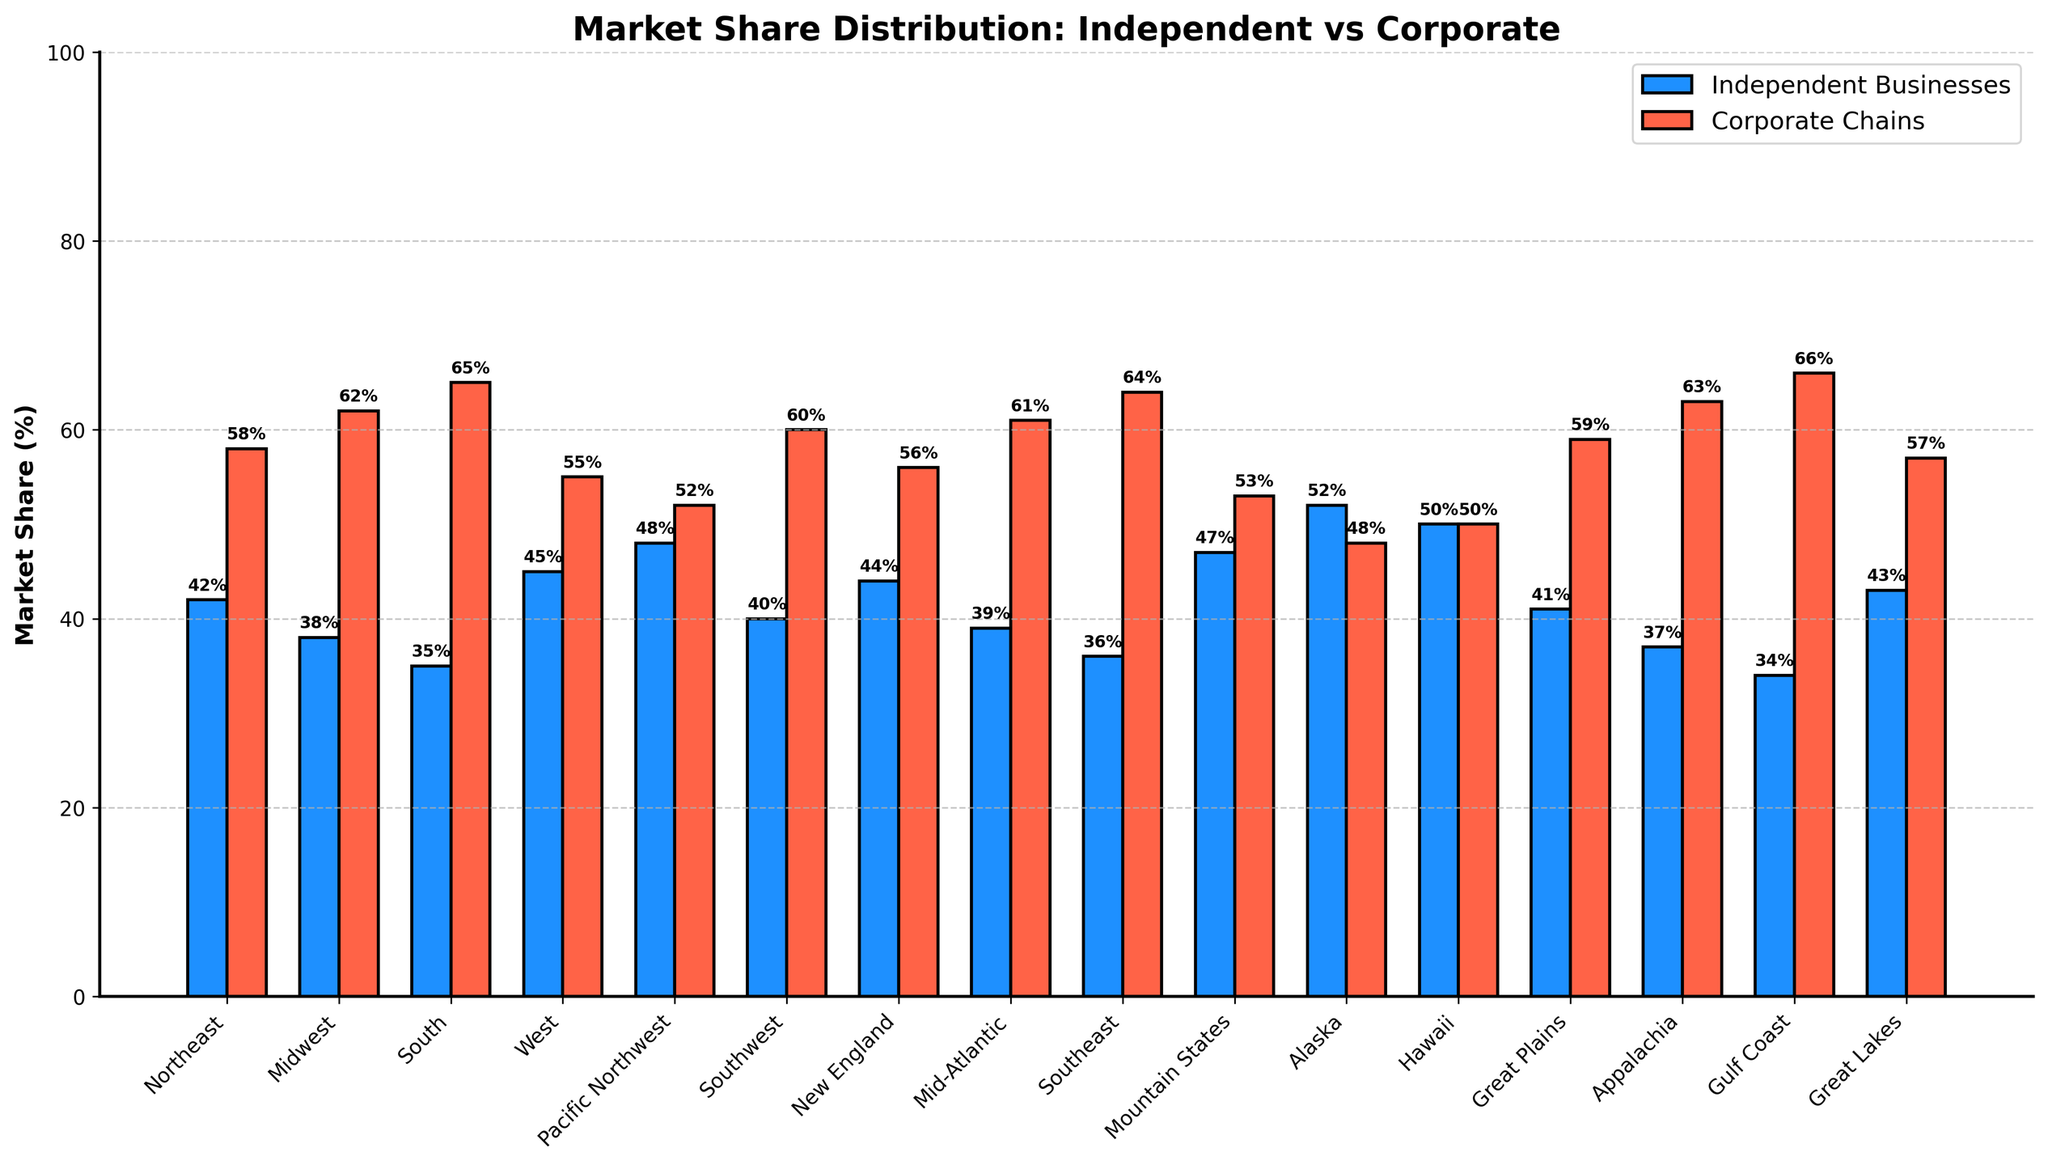Which region has the highest market share for independent businesses? The bars representing independent businesses are blue. The tallest blue bar corresponds to Alaska with a height of 52%.
Answer: Alaska Which region in the Northeast has a higher market share, independent businesses or corporate chains? In the Northeast, the blue bar represents independent businesses at 42%, and the red bar represents corporate chains at 58%. 58% (corporate chains) is higher than 42% (independent businesses).
Answer: Corporate Chains What is the difference in market share between independent businesses and corporate chains in the Pacific Northwest? In the Pacific Northwest, the blue bar for independent businesses is at 48%, and the red bar for corporate chains is at 52%. The difference is
Answer: 4% What is the average market share of independent businesses across all regions? Sum the market shares of independent businesses across all 16 regions: (42 + 38 + 35 + 45 + 48 + 40 + 44 + 39 + 36 + 47 + 52 + 50 + 41 + 37 + 34 + 43) = 671. Divide by 16 regions: 671 / 16 = 41.94.
Answer: 41.94 Which regions have an equal market share for both independent businesses and corporate chains? The bars representing independent businesses and corporate chains are of equal height in Hawaii at 50%.
Answer: Hawaii Compare the market share of independent businesses in the West and Great Lakes regions. Which one is higher? In the West, the market share for independent businesses is represented by a blue bar at 45%. In the Great Lakes, the blue bar is at 43%. 45% is higher than 43%.
Answer: West In which regions do corporate chains have more than a 60% market share? Regions where the red bar (corporate chains) exceeds 60% are the Midwest (62%), South (65%), Mid-Atlantic (61%), Appalachia (63%), and Gulf Coast (66%).
Answer: Midwest, South, Mid-Atlantic, Appalachia, Gulf Coast What is the combined market share of independent businesses in the Southwest and Southeast regions? In the Southwest, the market share is 40%, and in the Southeast, it is 36%. Combined it is 40% + 36% = 76%.
Answer: 76% What region has the smallest difference in market share between independent businesses and corporate chains? Hawaii has independent businesses at 50% and corporate chains at 50%, yielding a difference of 0%.
Answer: Hawaii How much more market share do corporate chains have compared to independent businesses in the Gulf Coast region? In the Gulf Coast, independent businesses have 34%, and corporate chains have 66%. The difference is 66% - 34% = 32%.
Answer: 32% 